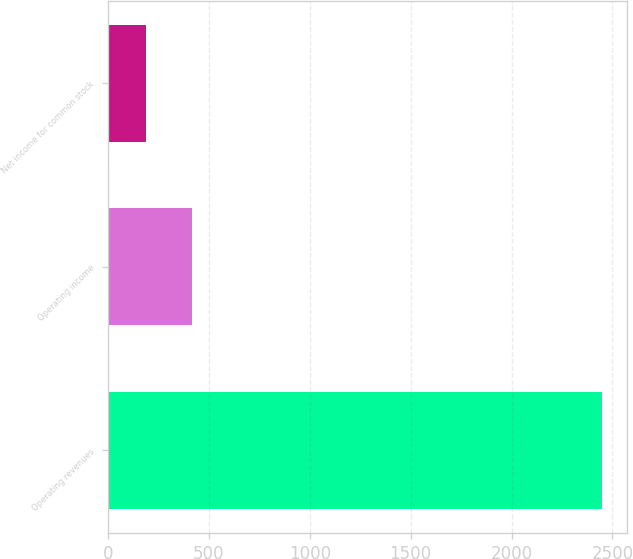Convert chart. <chart><loc_0><loc_0><loc_500><loc_500><bar_chart><fcel>Operating revenues<fcel>Operating income<fcel>Net income for common stock<nl><fcel>2449<fcel>415<fcel>189<nl></chart> 